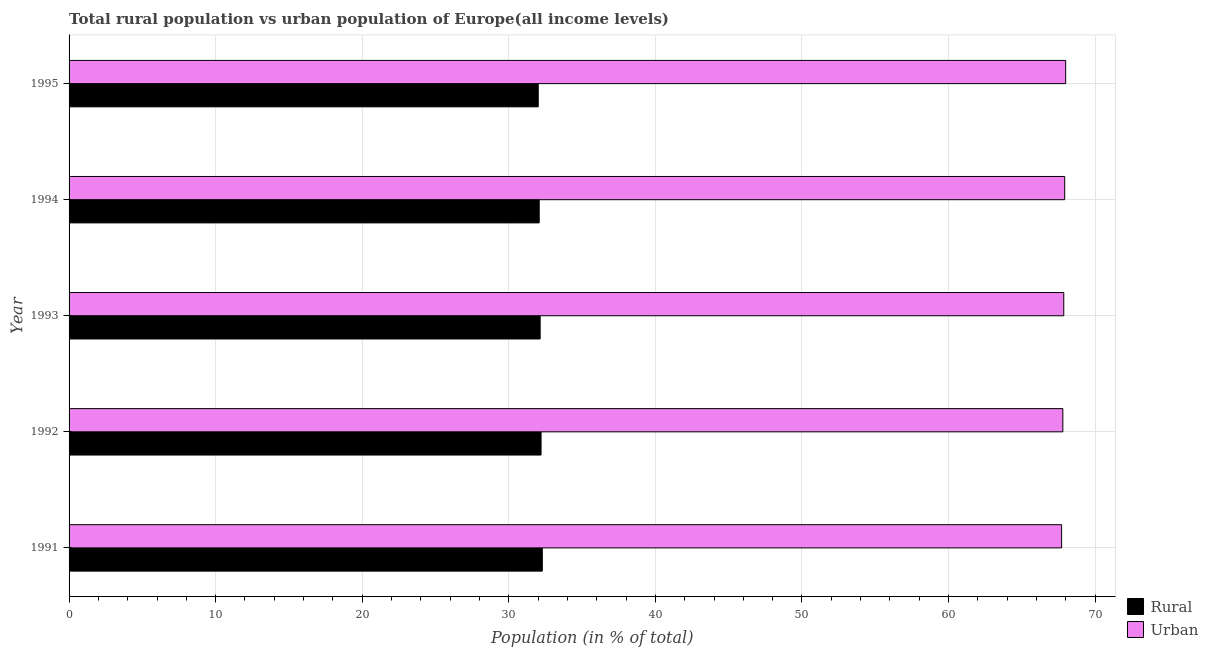How many different coloured bars are there?
Make the answer very short. 2. Are the number of bars per tick equal to the number of legend labels?
Provide a succinct answer. Yes. How many bars are there on the 3rd tick from the bottom?
Your answer should be very brief. 2. What is the label of the 5th group of bars from the top?
Your response must be concise. 1991. In how many cases, is the number of bars for a given year not equal to the number of legend labels?
Your answer should be very brief. 0. What is the urban population in 1994?
Give a very brief answer. 67.93. Across all years, what is the maximum rural population?
Make the answer very short. 32.29. Across all years, what is the minimum rural population?
Offer a terse response. 32.01. In which year was the urban population maximum?
Make the answer very short. 1995. What is the total urban population in the graph?
Your answer should be very brief. 339.29. What is the difference between the rural population in 1993 and that in 1995?
Offer a terse response. 0.13. What is the difference between the rural population in 1995 and the urban population in 1991?
Your answer should be compact. -35.71. What is the average rural population per year?
Ensure brevity in your answer.  32.14. In the year 1991, what is the difference between the urban population and rural population?
Your answer should be very brief. 35.43. Is the difference between the urban population in 1991 and 1994 greater than the difference between the rural population in 1991 and 1994?
Your answer should be very brief. No. What is the difference between the highest and the second highest urban population?
Ensure brevity in your answer.  0.07. What is the difference between the highest and the lowest urban population?
Your answer should be very brief. 0.28. Is the sum of the urban population in 1992 and 1995 greater than the maximum rural population across all years?
Your response must be concise. Yes. What does the 2nd bar from the top in 1992 represents?
Keep it short and to the point. Rural. What does the 2nd bar from the bottom in 1995 represents?
Ensure brevity in your answer.  Urban. Are all the bars in the graph horizontal?
Offer a very short reply. Yes. How many years are there in the graph?
Your response must be concise. 5. Does the graph contain any zero values?
Ensure brevity in your answer.  No. Where does the legend appear in the graph?
Provide a short and direct response. Bottom right. How are the legend labels stacked?
Ensure brevity in your answer.  Vertical. What is the title of the graph?
Give a very brief answer. Total rural population vs urban population of Europe(all income levels). What is the label or title of the X-axis?
Make the answer very short. Population (in % of total). What is the Population (in % of total) of Rural in 1991?
Give a very brief answer. 32.29. What is the Population (in % of total) in Urban in 1991?
Provide a succinct answer. 67.71. What is the Population (in % of total) of Rural in 1992?
Offer a very short reply. 32.2. What is the Population (in % of total) in Urban in 1992?
Your answer should be compact. 67.8. What is the Population (in % of total) in Rural in 1993?
Your answer should be very brief. 32.14. What is the Population (in % of total) in Urban in 1993?
Your answer should be compact. 67.86. What is the Population (in % of total) of Rural in 1994?
Keep it short and to the point. 32.07. What is the Population (in % of total) in Urban in 1994?
Your answer should be compact. 67.93. What is the Population (in % of total) of Rural in 1995?
Your response must be concise. 32.01. What is the Population (in % of total) in Urban in 1995?
Offer a terse response. 67.99. Across all years, what is the maximum Population (in % of total) of Rural?
Make the answer very short. 32.29. Across all years, what is the maximum Population (in % of total) in Urban?
Your answer should be very brief. 67.99. Across all years, what is the minimum Population (in % of total) in Rural?
Your answer should be very brief. 32.01. Across all years, what is the minimum Population (in % of total) in Urban?
Your response must be concise. 67.71. What is the total Population (in % of total) of Rural in the graph?
Make the answer very short. 160.71. What is the total Population (in % of total) of Urban in the graph?
Offer a very short reply. 339.29. What is the difference between the Population (in % of total) in Rural in 1991 and that in 1992?
Provide a succinct answer. 0.08. What is the difference between the Population (in % of total) of Urban in 1991 and that in 1992?
Your answer should be very brief. -0.08. What is the difference between the Population (in % of total) in Rural in 1991 and that in 1993?
Offer a terse response. 0.15. What is the difference between the Population (in % of total) in Urban in 1991 and that in 1993?
Your answer should be compact. -0.15. What is the difference between the Population (in % of total) of Rural in 1991 and that in 1994?
Offer a terse response. 0.21. What is the difference between the Population (in % of total) in Urban in 1991 and that in 1994?
Your response must be concise. -0.21. What is the difference between the Population (in % of total) of Rural in 1991 and that in 1995?
Offer a terse response. 0.28. What is the difference between the Population (in % of total) in Urban in 1991 and that in 1995?
Offer a terse response. -0.28. What is the difference between the Population (in % of total) of Rural in 1992 and that in 1993?
Offer a very short reply. 0.06. What is the difference between the Population (in % of total) in Urban in 1992 and that in 1993?
Your answer should be compact. -0.06. What is the difference between the Population (in % of total) in Rural in 1992 and that in 1994?
Provide a short and direct response. 0.13. What is the difference between the Population (in % of total) of Urban in 1992 and that in 1994?
Ensure brevity in your answer.  -0.13. What is the difference between the Population (in % of total) of Rural in 1992 and that in 1995?
Ensure brevity in your answer.  0.19. What is the difference between the Population (in % of total) of Urban in 1992 and that in 1995?
Make the answer very short. -0.19. What is the difference between the Population (in % of total) in Rural in 1993 and that in 1994?
Make the answer very short. 0.06. What is the difference between the Population (in % of total) of Urban in 1993 and that in 1994?
Provide a succinct answer. -0.06. What is the difference between the Population (in % of total) of Rural in 1993 and that in 1995?
Provide a succinct answer. 0.13. What is the difference between the Population (in % of total) of Urban in 1993 and that in 1995?
Give a very brief answer. -0.13. What is the difference between the Population (in % of total) in Rural in 1994 and that in 1995?
Offer a very short reply. 0.07. What is the difference between the Population (in % of total) in Urban in 1994 and that in 1995?
Ensure brevity in your answer.  -0.07. What is the difference between the Population (in % of total) of Rural in 1991 and the Population (in % of total) of Urban in 1992?
Offer a terse response. -35.51. What is the difference between the Population (in % of total) of Rural in 1991 and the Population (in % of total) of Urban in 1993?
Your answer should be compact. -35.58. What is the difference between the Population (in % of total) in Rural in 1991 and the Population (in % of total) in Urban in 1994?
Offer a terse response. -35.64. What is the difference between the Population (in % of total) in Rural in 1991 and the Population (in % of total) in Urban in 1995?
Offer a very short reply. -35.71. What is the difference between the Population (in % of total) in Rural in 1992 and the Population (in % of total) in Urban in 1993?
Make the answer very short. -35.66. What is the difference between the Population (in % of total) of Rural in 1992 and the Population (in % of total) of Urban in 1994?
Provide a succinct answer. -35.73. What is the difference between the Population (in % of total) in Rural in 1992 and the Population (in % of total) in Urban in 1995?
Give a very brief answer. -35.79. What is the difference between the Population (in % of total) of Rural in 1993 and the Population (in % of total) of Urban in 1994?
Provide a short and direct response. -35.79. What is the difference between the Population (in % of total) in Rural in 1993 and the Population (in % of total) in Urban in 1995?
Your answer should be compact. -35.85. What is the difference between the Population (in % of total) of Rural in 1994 and the Population (in % of total) of Urban in 1995?
Provide a short and direct response. -35.92. What is the average Population (in % of total) of Rural per year?
Provide a short and direct response. 32.14. What is the average Population (in % of total) in Urban per year?
Provide a short and direct response. 67.86. In the year 1991, what is the difference between the Population (in % of total) of Rural and Population (in % of total) of Urban?
Make the answer very short. -35.43. In the year 1992, what is the difference between the Population (in % of total) in Rural and Population (in % of total) in Urban?
Keep it short and to the point. -35.6. In the year 1993, what is the difference between the Population (in % of total) in Rural and Population (in % of total) in Urban?
Provide a succinct answer. -35.72. In the year 1994, what is the difference between the Population (in % of total) of Rural and Population (in % of total) of Urban?
Your response must be concise. -35.85. In the year 1995, what is the difference between the Population (in % of total) in Rural and Population (in % of total) in Urban?
Make the answer very short. -35.98. What is the ratio of the Population (in % of total) of Urban in 1991 to that in 1992?
Your answer should be very brief. 1. What is the ratio of the Population (in % of total) in Urban in 1991 to that in 1993?
Offer a very short reply. 1. What is the ratio of the Population (in % of total) in Rural in 1991 to that in 1994?
Provide a succinct answer. 1.01. What is the ratio of the Population (in % of total) in Urban in 1991 to that in 1994?
Ensure brevity in your answer.  1. What is the ratio of the Population (in % of total) in Rural in 1991 to that in 1995?
Provide a short and direct response. 1.01. What is the ratio of the Population (in % of total) of Urban in 1991 to that in 1995?
Your answer should be very brief. 1. What is the ratio of the Population (in % of total) of Rural in 1992 to that in 1993?
Your response must be concise. 1. What is the ratio of the Population (in % of total) of Rural in 1992 to that in 1994?
Your answer should be very brief. 1. What is the ratio of the Population (in % of total) of Urban in 1992 to that in 1994?
Your answer should be very brief. 1. What is the ratio of the Population (in % of total) of Rural in 1993 to that in 1994?
Provide a short and direct response. 1. What is the ratio of the Population (in % of total) in Rural in 1994 to that in 1995?
Provide a short and direct response. 1. What is the ratio of the Population (in % of total) in Urban in 1994 to that in 1995?
Give a very brief answer. 1. What is the difference between the highest and the second highest Population (in % of total) in Rural?
Offer a terse response. 0.08. What is the difference between the highest and the second highest Population (in % of total) of Urban?
Your response must be concise. 0.07. What is the difference between the highest and the lowest Population (in % of total) in Rural?
Give a very brief answer. 0.28. What is the difference between the highest and the lowest Population (in % of total) in Urban?
Provide a short and direct response. 0.28. 